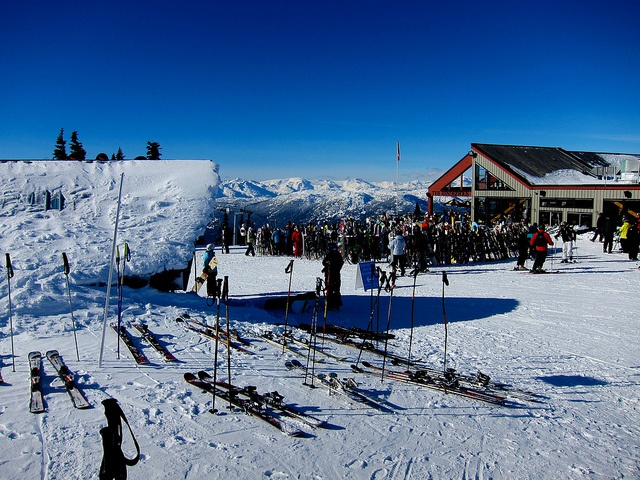Describe the objects in this image and their specific colors. I can see people in navy, black, gray, and darkgray tones, skis in navy, black, darkgray, and gray tones, skis in navy, black, gray, and darkgray tones, skis in navy, black, darkgray, and gray tones, and skis in navy, black, darkgray, and gray tones in this image. 